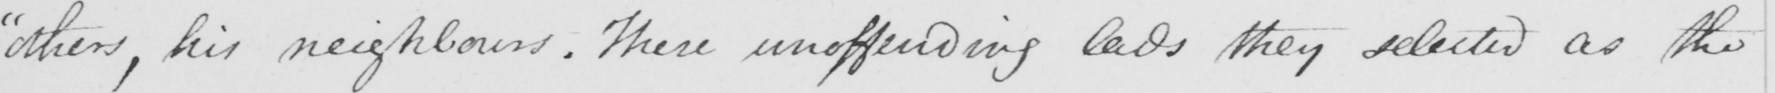Can you tell me what this handwritten text says? " others , his neighbors . These unoffending lads they selected as the 